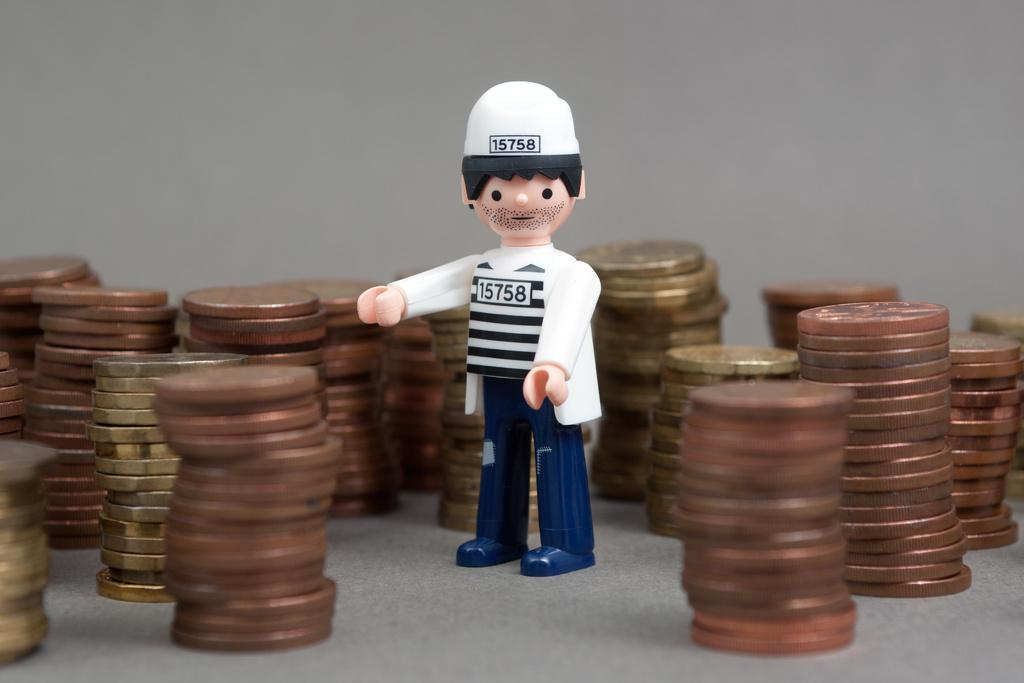What type of objects can be seen in the image? There are coins and a toy in the image. Can you describe the toy in the image? Unfortunately, the provided facts do not give any details about the toy, so we cannot describe it further. What type of cap is the jewel wearing in the image? There is no cap or jewel present in the image. 